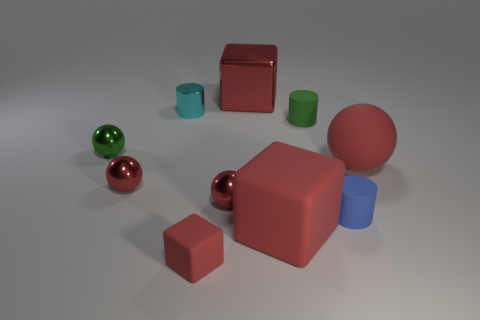Subtract all tiny cubes. How many cubes are left? 2 Subtract all green balls. How many balls are left? 3 Subtract all cubes. How many objects are left? 7 Subtract 2 cubes. How many cubes are left? 1 Add 5 red matte objects. How many red matte objects are left? 8 Add 10 gray balls. How many gray balls exist? 10 Subtract 0 gray cylinders. How many objects are left? 10 Subtract all blue cylinders. Subtract all yellow balls. How many cylinders are left? 2 Subtract all gray blocks. How many red balls are left? 3 Subtract all matte objects. Subtract all small blue matte cylinders. How many objects are left? 4 